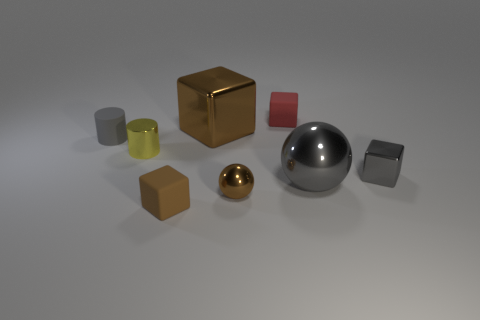If the largest object were to be used as a container, how many of the smallest objects in the image do you think could fit inside? If the largest object, which is the spherical silver one, were hollow and used as a container, it appears that it could fit numerous smallest objects inside which, in this image, seem to be the small yellow cylinder. Estimating by size comparison and assuming efficient packing, it might hold approximately 20 to 30 of these small cylinders. 